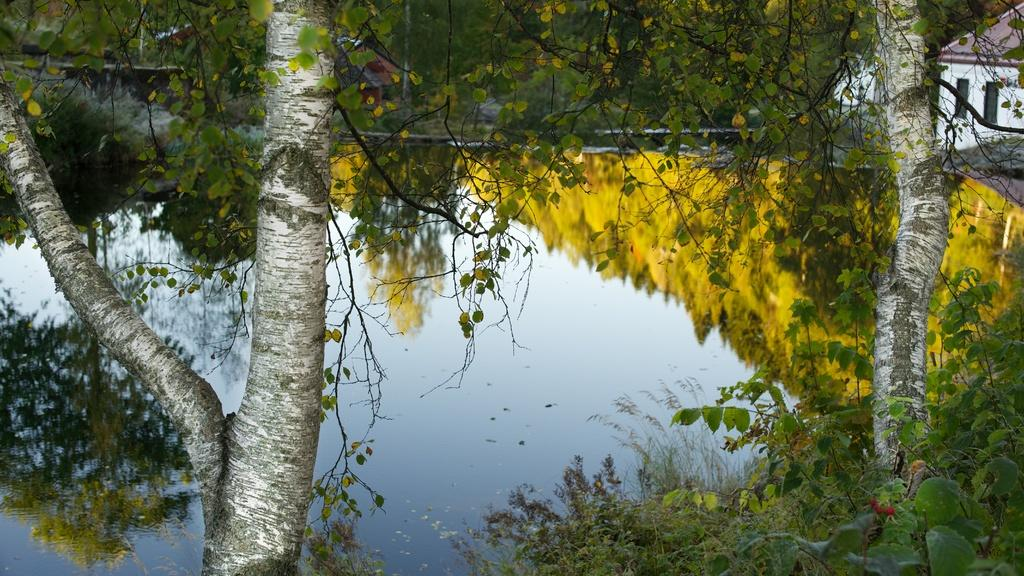What type of structure is visible in the picture? There is a house in the picture. What other elements can be seen in the picture besides the house? There are plants, as well as reflections of trees and the sky in the water. What type of prose is being recited by the ducks in the picture? There are no ducks present in the image, and therefore no prose is being recited. Is there a club visible in the picture? There is no club present in the image. 